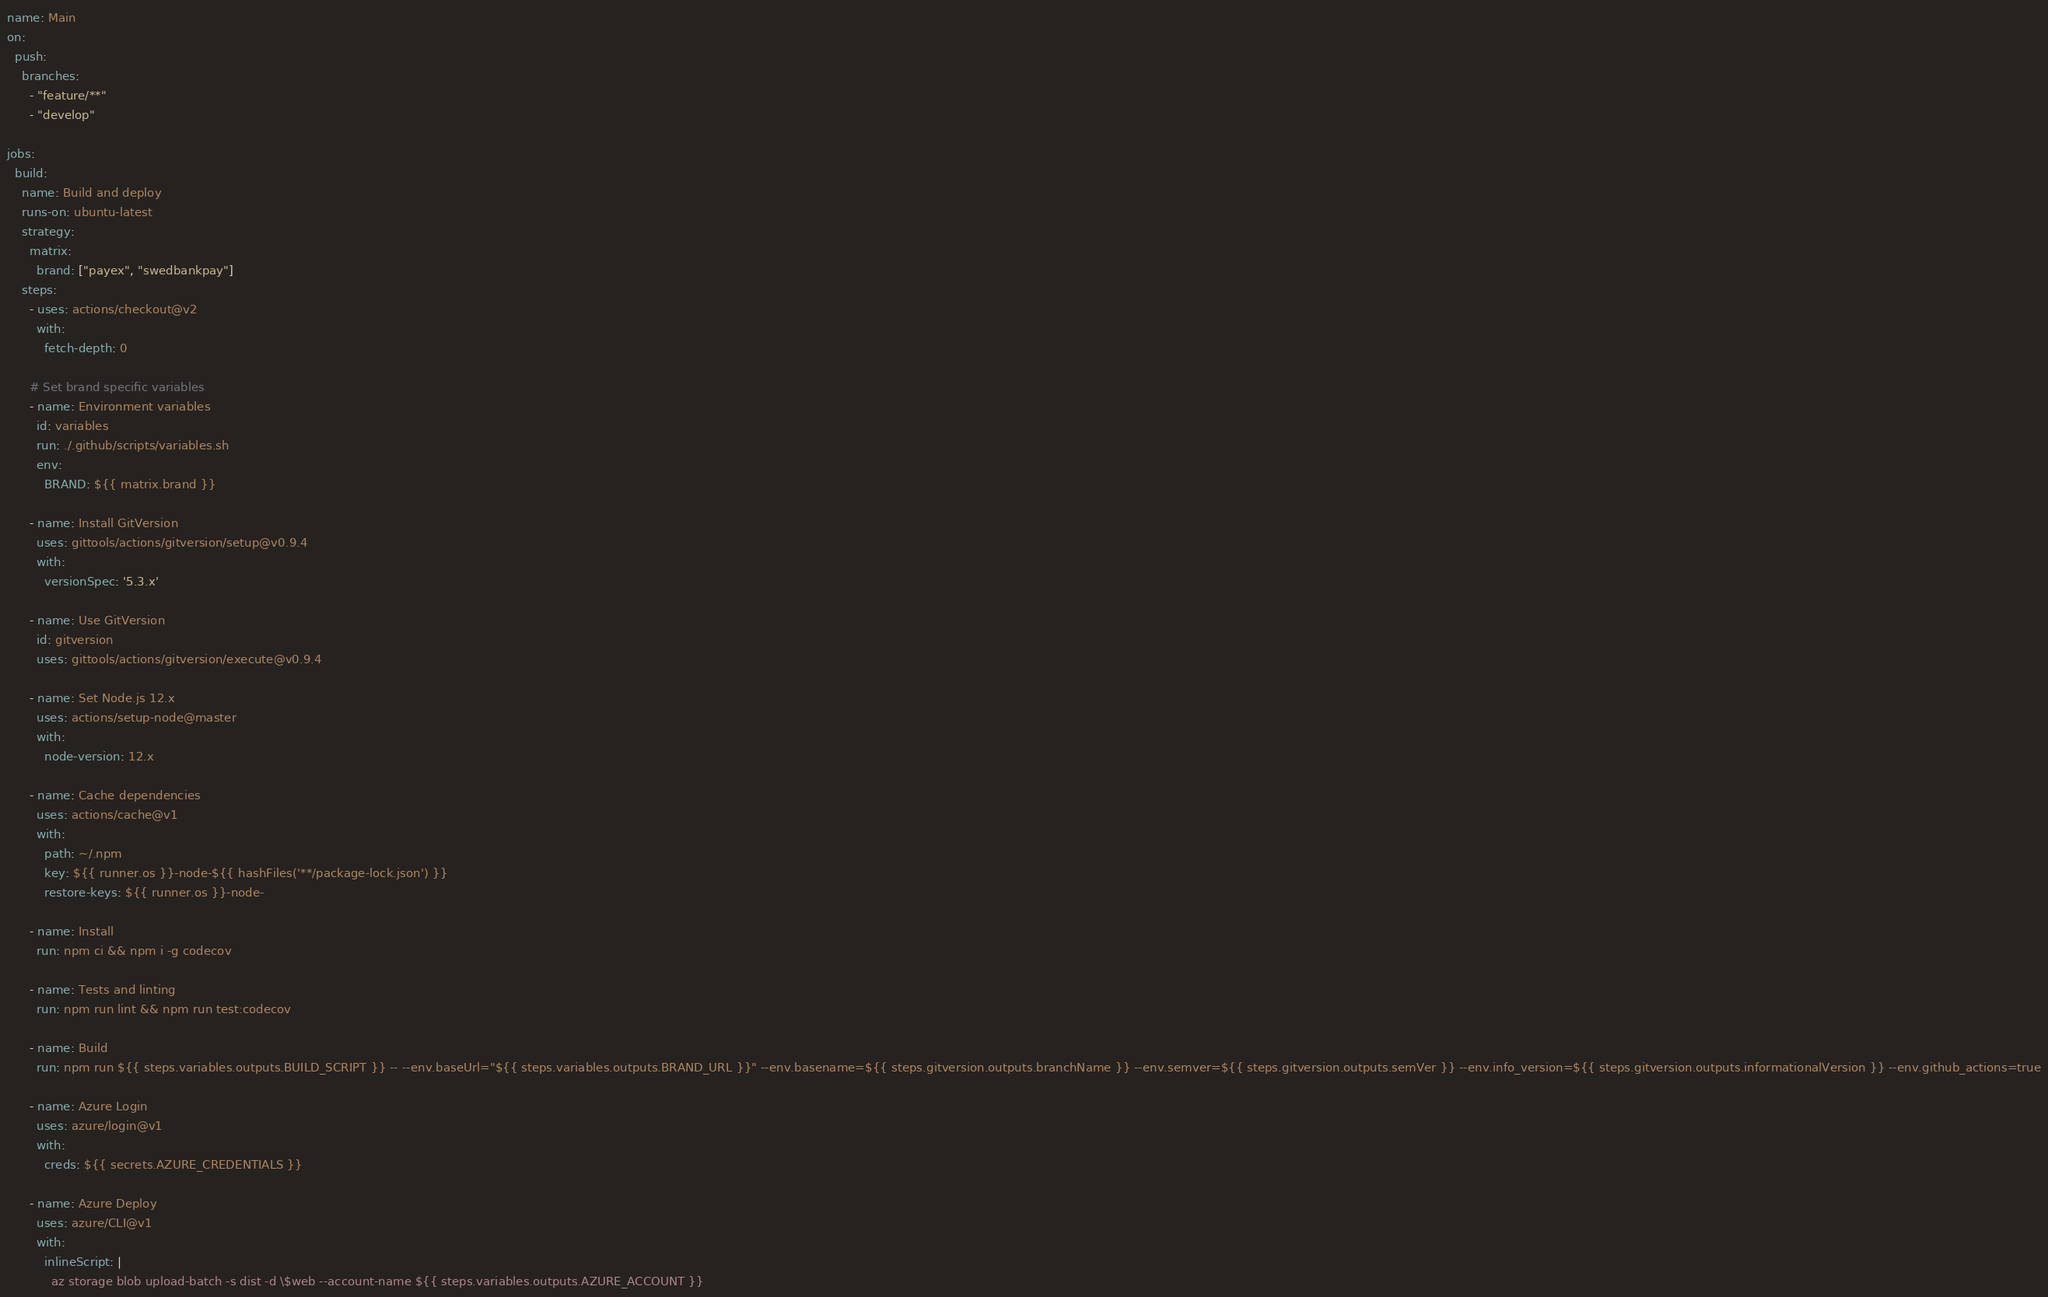Convert code to text. <code><loc_0><loc_0><loc_500><loc_500><_YAML_>name: Main
on: 
  push:
    branches:
      - "feature/**"
      - "develop"

jobs:
  build:
    name: Build and deploy
    runs-on: ubuntu-latest
    strategy:
      matrix:
        brand: ["payex", "swedbankpay"]
    steps:
      - uses: actions/checkout@v2
        with:
          fetch-depth: 0

      # Set brand specific variables
      - name: Environment variables
        id: variables
        run: ./.github/scripts/variables.sh
        env:
          BRAND: ${{ matrix.brand }}

      - name: Install GitVersion
        uses: gittools/actions/gitversion/setup@v0.9.4
        with:
          versionSpec: '5.3.x'

      - name: Use GitVersion
        id: gitversion
        uses: gittools/actions/gitversion/execute@v0.9.4

      - name: Set Node.js 12.x
        uses: actions/setup-node@master
        with:
          node-version: 12.x

      - name: Cache dependencies
        uses: actions/cache@v1
        with:
          path: ~/.npm
          key: ${{ runner.os }}-node-${{ hashFiles('**/package-lock.json') }}
          restore-keys: ${{ runner.os }}-node-

      - name: Install
        run: npm ci && npm i -g codecov

      - name: Tests and linting
        run: npm run lint && npm run test:codecov

      - name: Build
        run: npm run ${{ steps.variables.outputs.BUILD_SCRIPT }} -- --env.baseUrl="${{ steps.variables.outputs.BRAND_URL }}" --env.basename=${{ steps.gitversion.outputs.branchName }} --env.semver=${{ steps.gitversion.outputs.semVer }} --env.info_version=${{ steps.gitversion.outputs.informationalVersion }} --env.github_actions=true

      - name: Azure Login
        uses: azure/login@v1
        with:
          creds: ${{ secrets.AZURE_CREDENTIALS }}

      - name: Azure Deploy
        uses: azure/CLI@v1
        with:
          inlineScript: |
            az storage blob upload-batch -s dist -d \$web --account-name ${{ steps.variables.outputs.AZURE_ACCOUNT }}</code> 